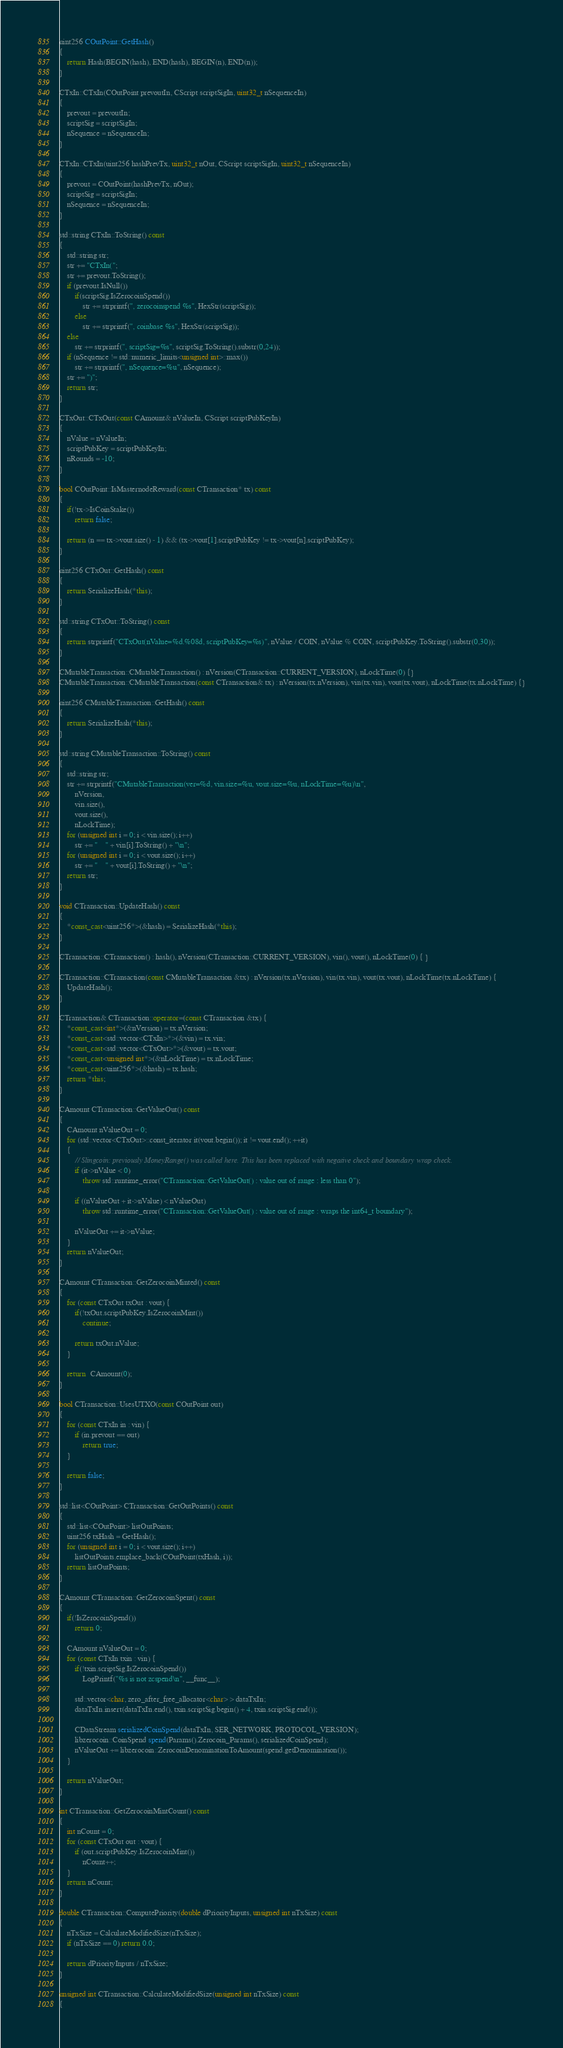Convert code to text. <code><loc_0><loc_0><loc_500><loc_500><_C++_>uint256 COutPoint::GetHash()
{
    return Hash(BEGIN(hash), END(hash), BEGIN(n), END(n));
}

CTxIn::CTxIn(COutPoint prevoutIn, CScript scriptSigIn, uint32_t nSequenceIn)
{
    prevout = prevoutIn;
    scriptSig = scriptSigIn;
    nSequence = nSequenceIn;
}

CTxIn::CTxIn(uint256 hashPrevTx, uint32_t nOut, CScript scriptSigIn, uint32_t nSequenceIn)
{
    prevout = COutPoint(hashPrevTx, nOut);
    scriptSig = scriptSigIn;
    nSequence = nSequenceIn;
}

std::string CTxIn::ToString() const
{
    std::string str;
    str += "CTxIn(";
    str += prevout.ToString();
    if (prevout.IsNull())
        if(scriptSig.IsZerocoinSpend())
            str += strprintf(", zerocoinspend %s", HexStr(scriptSig));
        else
            str += strprintf(", coinbase %s", HexStr(scriptSig));
    else
        str += strprintf(", scriptSig=%s", scriptSig.ToString().substr(0,24));
    if (nSequence != std::numeric_limits<unsigned int>::max())
        str += strprintf(", nSequence=%u", nSequence);
    str += ")";
    return str;
}

CTxOut::CTxOut(const CAmount& nValueIn, CScript scriptPubKeyIn)
{
    nValue = nValueIn;
    scriptPubKey = scriptPubKeyIn;
    nRounds = -10;
}

bool COutPoint::IsMasternodeReward(const CTransaction* tx) const
{
    if(!tx->IsCoinStake())
        return false;

    return (n == tx->vout.size() - 1) && (tx->vout[1].scriptPubKey != tx->vout[n].scriptPubKey);
}

uint256 CTxOut::GetHash() const
{
    return SerializeHash(*this);
}

std::string CTxOut::ToString() const
{
    return strprintf("CTxOut(nValue=%d.%08d, scriptPubKey=%s)", nValue / COIN, nValue % COIN, scriptPubKey.ToString().substr(0,30));
}

CMutableTransaction::CMutableTransaction() : nVersion(CTransaction::CURRENT_VERSION), nLockTime(0) {}
CMutableTransaction::CMutableTransaction(const CTransaction& tx) : nVersion(tx.nVersion), vin(tx.vin), vout(tx.vout), nLockTime(tx.nLockTime) {}

uint256 CMutableTransaction::GetHash() const
{
    return SerializeHash(*this);
}

std::string CMutableTransaction::ToString() const
{
    std::string str;
    str += strprintf("CMutableTransaction(ver=%d, vin.size=%u, vout.size=%u, nLockTime=%u)\n",
        nVersion,
        vin.size(),
        vout.size(),
        nLockTime);
    for (unsigned int i = 0; i < vin.size(); i++)
        str += "    " + vin[i].ToString() + "\n";
    for (unsigned int i = 0; i < vout.size(); i++)
        str += "    " + vout[i].ToString() + "\n";
    return str;
}

void CTransaction::UpdateHash() const
{
    *const_cast<uint256*>(&hash) = SerializeHash(*this);
}

CTransaction::CTransaction() : hash(), nVersion(CTransaction::CURRENT_VERSION), vin(), vout(), nLockTime(0) { }

CTransaction::CTransaction(const CMutableTransaction &tx) : nVersion(tx.nVersion), vin(tx.vin), vout(tx.vout), nLockTime(tx.nLockTime) {
    UpdateHash();
}

CTransaction& CTransaction::operator=(const CTransaction &tx) {
    *const_cast<int*>(&nVersion) = tx.nVersion;
    *const_cast<std::vector<CTxIn>*>(&vin) = tx.vin;
    *const_cast<std::vector<CTxOut>*>(&vout) = tx.vout;
    *const_cast<unsigned int*>(&nLockTime) = tx.nLockTime;
    *const_cast<uint256*>(&hash) = tx.hash;
    return *this;
}

CAmount CTransaction::GetValueOut() const
{
    CAmount nValueOut = 0;
    for (std::vector<CTxOut>::const_iterator it(vout.begin()); it != vout.end(); ++it)
    {
        // Slingcoin: previously MoneyRange() was called here. This has been replaced with negative check and boundary wrap check.
        if (it->nValue < 0)
            throw std::runtime_error("CTransaction::GetValueOut() : value out of range : less than 0");

        if ((nValueOut + it->nValue) < nValueOut)
            throw std::runtime_error("CTransaction::GetValueOut() : value out of range : wraps the int64_t boundary");

        nValueOut += it->nValue;
    }
    return nValueOut;
}

CAmount CTransaction::GetZerocoinMinted() const
{
    for (const CTxOut txOut : vout) {
        if(!txOut.scriptPubKey.IsZerocoinMint())
            continue;

        return txOut.nValue;
    }

    return  CAmount(0);
}

bool CTransaction::UsesUTXO(const COutPoint out)
{
    for (const CTxIn in : vin) {
        if (in.prevout == out)
            return true;
    }

    return false;
}

std::list<COutPoint> CTransaction::GetOutPoints() const
{
    std::list<COutPoint> listOutPoints;
    uint256 txHash = GetHash();
    for (unsigned int i = 0; i < vout.size(); i++)
        listOutPoints.emplace_back(COutPoint(txHash, i));
    return listOutPoints;
}

CAmount CTransaction::GetZerocoinSpent() const
{
    if(!IsZerocoinSpend())
        return 0;

    CAmount nValueOut = 0;
    for (const CTxIn txin : vin) {
        if(!txin.scriptSig.IsZerocoinSpend())
            LogPrintf("%s is not zcspend\n", __func__);

        std::vector<char, zero_after_free_allocator<char> > dataTxIn;
        dataTxIn.insert(dataTxIn.end(), txin.scriptSig.begin() + 4, txin.scriptSig.end());

        CDataStream serializedCoinSpend(dataTxIn, SER_NETWORK, PROTOCOL_VERSION);
        libzerocoin::CoinSpend spend(Params().Zerocoin_Params(), serializedCoinSpend);
        nValueOut += libzerocoin::ZerocoinDenominationToAmount(spend.getDenomination());
    }

    return nValueOut;
}

int CTransaction::GetZerocoinMintCount() const
{
    int nCount = 0;
    for (const CTxOut out : vout) {
        if (out.scriptPubKey.IsZerocoinMint())
            nCount++;
    }
    return nCount;
}

double CTransaction::ComputePriority(double dPriorityInputs, unsigned int nTxSize) const
{
    nTxSize = CalculateModifiedSize(nTxSize);
    if (nTxSize == 0) return 0.0;

    return dPriorityInputs / nTxSize;
}

unsigned int CTransaction::CalculateModifiedSize(unsigned int nTxSize) const
{</code> 